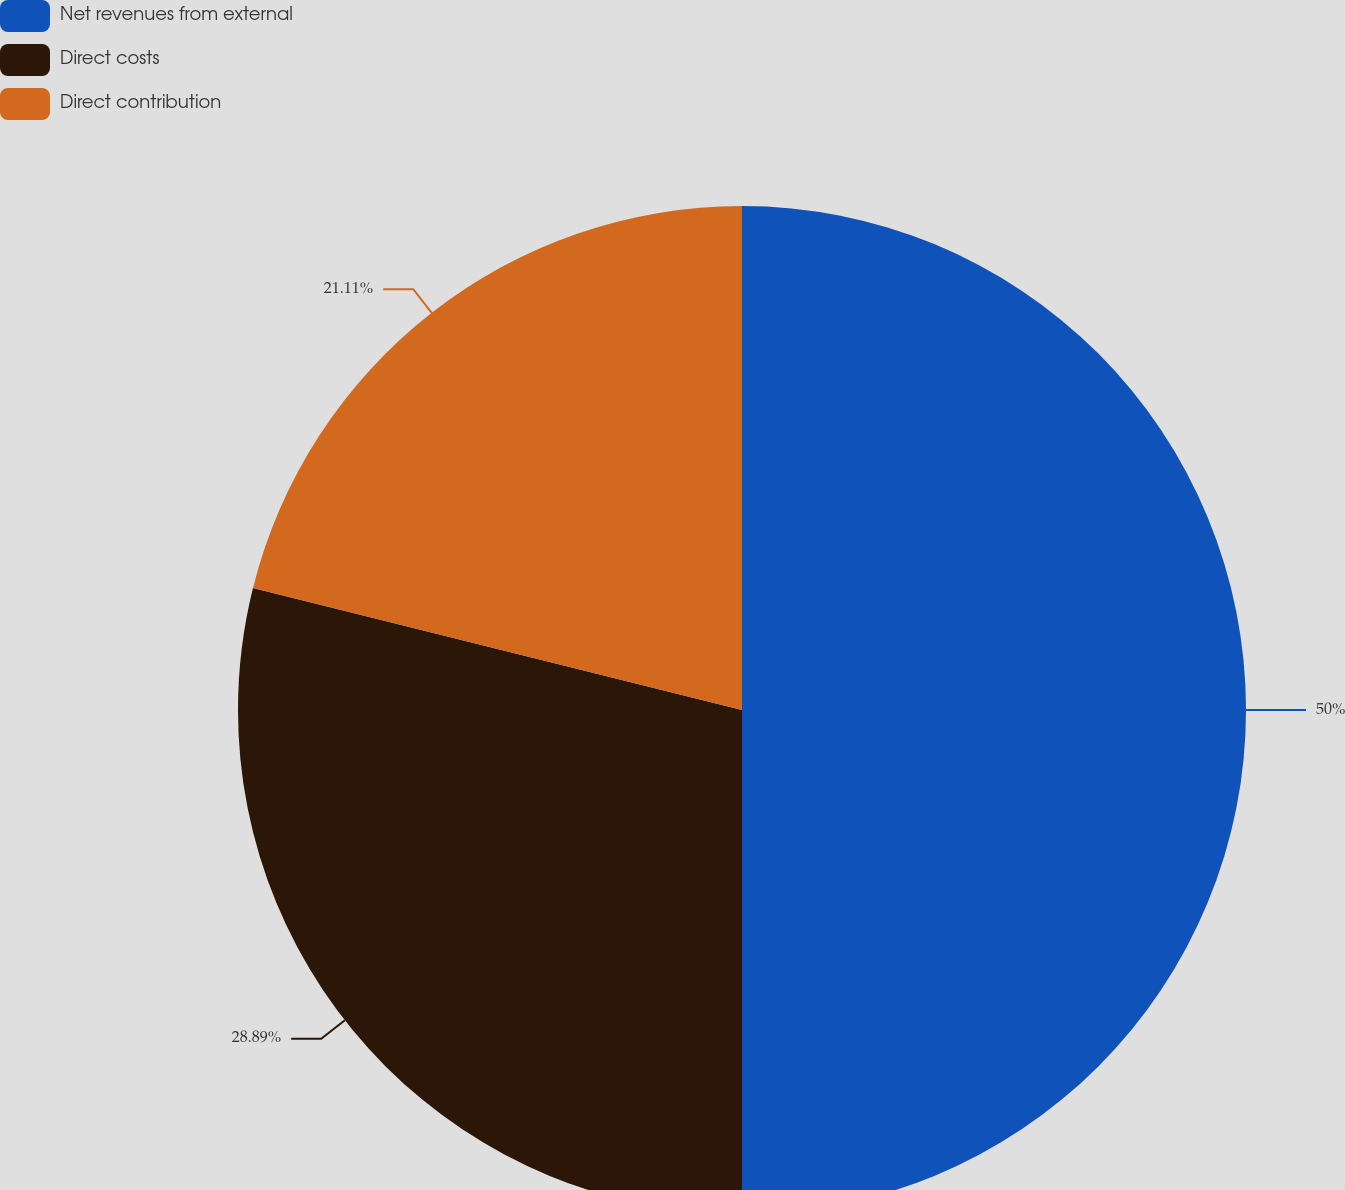Convert chart. <chart><loc_0><loc_0><loc_500><loc_500><pie_chart><fcel>Net revenues from external<fcel>Direct costs<fcel>Direct contribution<nl><fcel>50.0%<fcel>28.89%<fcel>21.11%<nl></chart> 